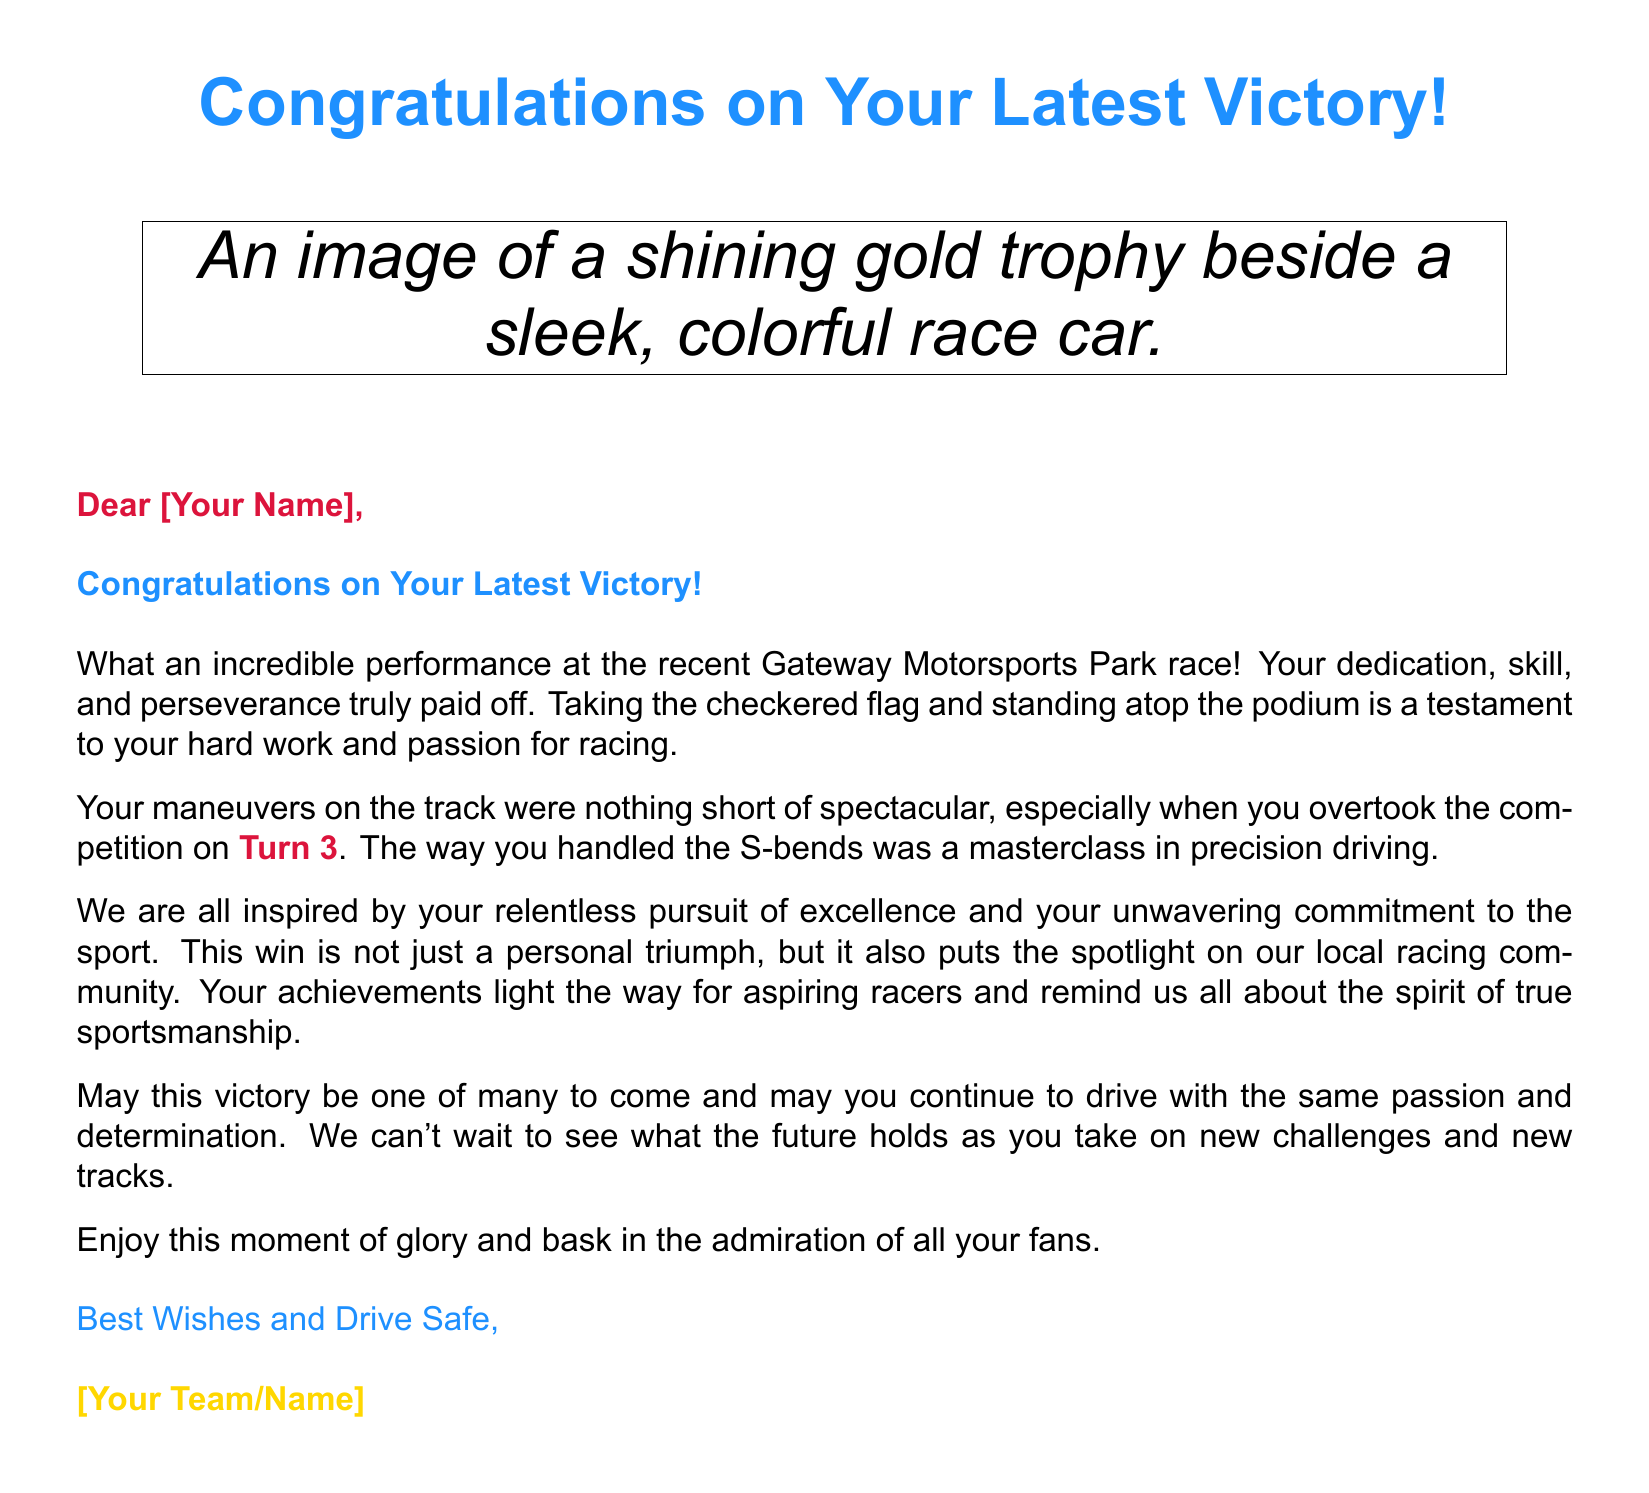What is the title of the card? The title of the card is prominently displayed at the top using a bright blue color.
Answer: Congratulations on Your Latest Victory! What color is the trophy in the image? The card describes the trophy as "shining gold," indicating its color.
Answer: Gold What racing track is mentioned? The card references the specific location where the race took place, indicating its significance to the achievement.
Answer: Gateway Motorsports Park Which turn is highlighted for an impressive maneuver? The document specifies a particular turn where a notable racing maneuver occurred, illustrating exceptional driving skill.
Answer: Turn 3 How is the message signed? The closing of the card uses a specific phrase to convey well wishes unique to the greeting card format.
Answer: Best Wishes and Drive Safe What is the main emotion conveyed in the card? The card primarily expresses admiration and celebration of the recipient's accomplishments, emphasizing feelings of inspiration.
Answer: Congratulations Who is the card addressed to? The card mentions a placeholder for the name of the person receiving the congratulations, indicating a personal touch.
Answer: [Your Name] What type of community does the card reference? The message highlights the impact of the recipient's victory on a particular group involved in racing, emphasizing pride.
Answer: Local racing community What kind of driving techniques are mentioned? The card references specific driving techniques that demonstrate the recipient's skill level, showcasing high-performance racing.
Answer: Precision driving 